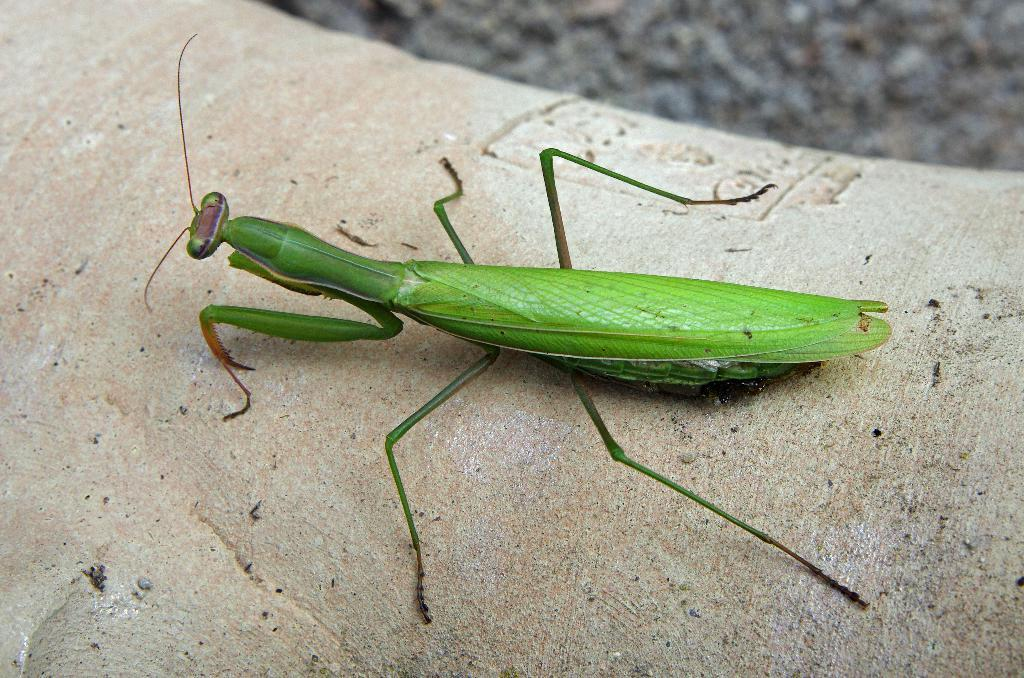What type of creature is present in the image? There is a green color insect in the image. What type of dress is the girl wearing in the image? There is no girl present in the image, only a green color insect. 